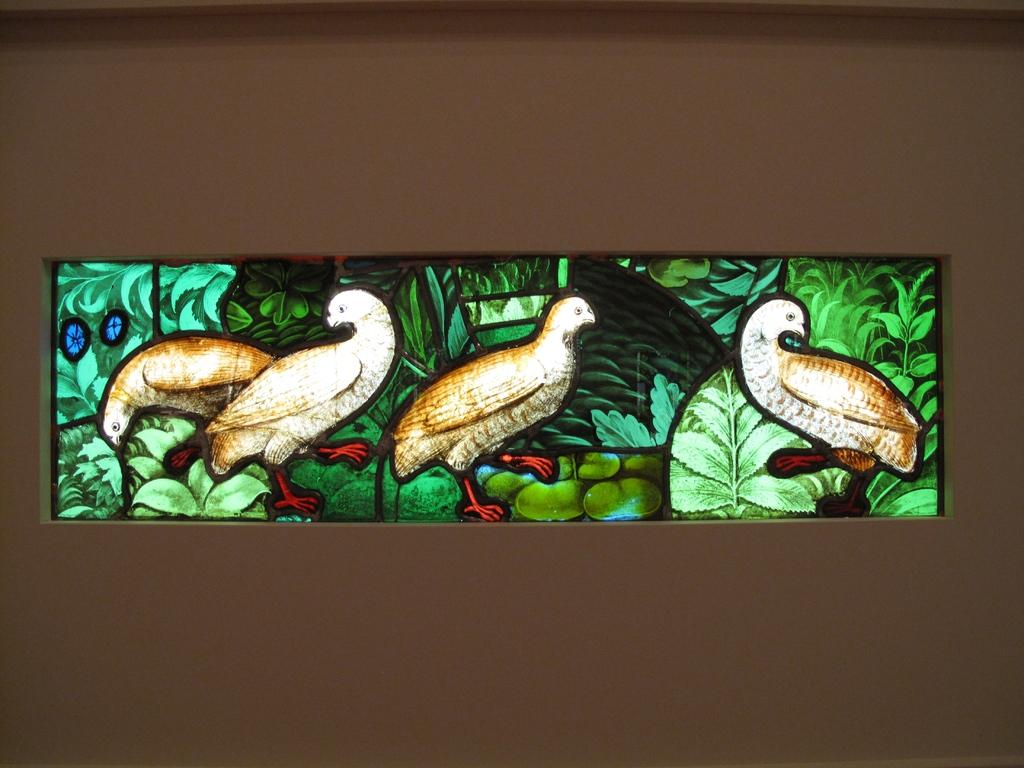What is depicted in the center of the image? There is an art of pigeons, trees, and plants in the center of the image. What can be seen in the background of the image? There is a wall visible in the background of the image. What type of needle is being used to control the noise in the image? There is no needle or noise present in the image; it features an art piece with pigeons, trees, and plants in the center and a wall in the background. 